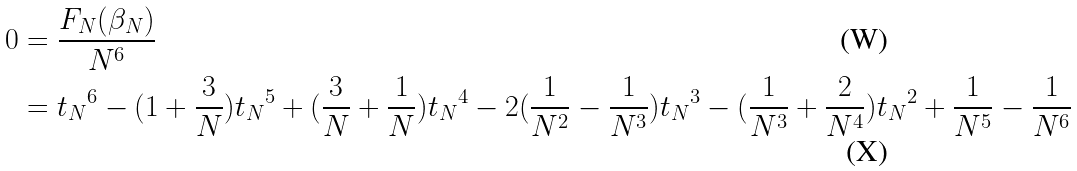Convert formula to latex. <formula><loc_0><loc_0><loc_500><loc_500>0 & = \frac { F _ { N } ( \beta _ { N } ) } { N ^ { 6 } } \\ & = { t _ { N } } ^ { 6 } - ( 1 + \frac { 3 } { N } ) { t _ { N } } ^ { 5 } + ( \frac { 3 } { N } + \frac { 1 } { N } ) { t _ { N } } ^ { 4 } - 2 ( \frac { 1 } { N ^ { 2 } } - \frac { 1 } { N ^ { 3 } } ) { t _ { N } } ^ { 3 } - ( \frac { 1 } { N ^ { 3 } } + \frac { 2 } { N ^ { 4 } } ) { t _ { N } } ^ { 2 } + \frac { 1 } { N ^ { 5 } } - \frac { 1 } { N ^ { 6 } }</formula> 